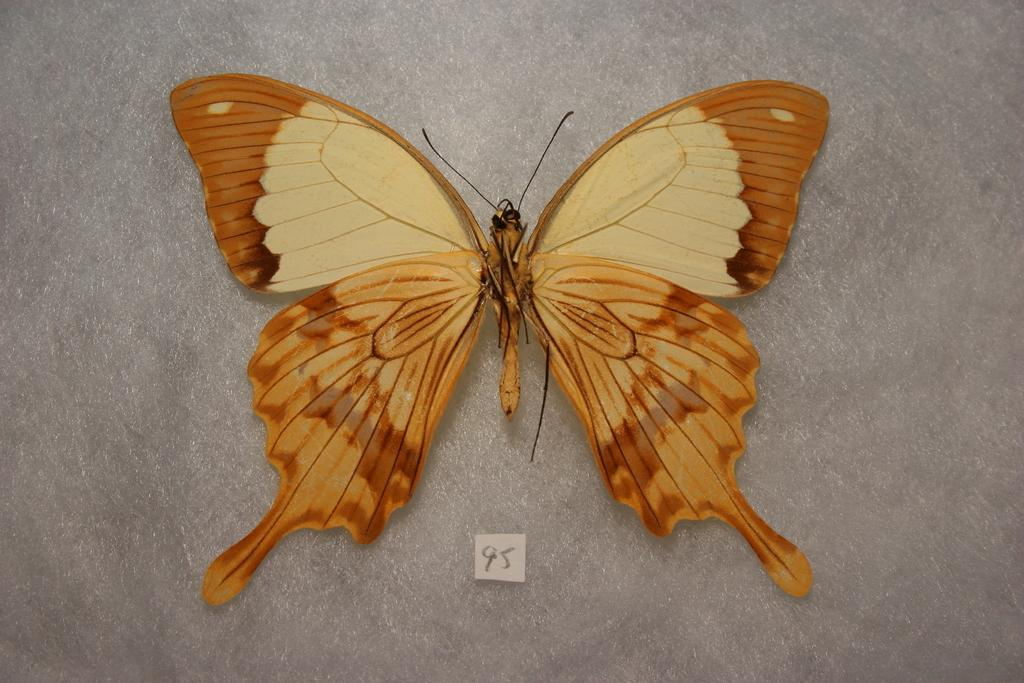What type of insect is present in the image? There is a butterfly in the image. What color is the butterfly? The butterfly is brown in color. What other object can be seen at the bottom of the image? There is a small piece of paper at the bottom of the image. What color is the background of the image? The background of the image is gray. What type of gate is visible in the image? There is no gate present in the image. What type of print can be seen on the butterfly's wings? The butterfly in the image is brown and does not have any visible prints on its wings. 